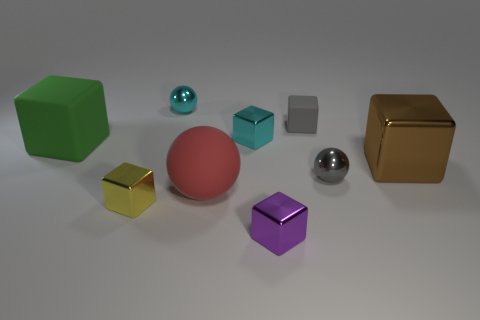What size is the cyan ball that is the same material as the brown cube?
Make the answer very short. Small. Are there any other things that have the same color as the small matte thing?
Ensure brevity in your answer.  Yes. Are the large brown object and the green block made of the same material?
Provide a succinct answer. No. What number of objects are big red metal blocks or green things?
Give a very brief answer. 1. The green object has what size?
Offer a terse response. Large. Is the number of big red spheres less than the number of small spheres?
Ensure brevity in your answer.  Yes. What number of other large blocks have the same color as the large metal cube?
Ensure brevity in your answer.  0. There is a shiny ball in front of the brown metal block; does it have the same color as the small matte thing?
Your response must be concise. Yes. What is the shape of the tiny cyan thing that is behind the gray block?
Provide a succinct answer. Sphere. There is a tiny yellow thing that is in front of the large matte ball; are there any tiny yellow objects left of it?
Keep it short and to the point. No. 